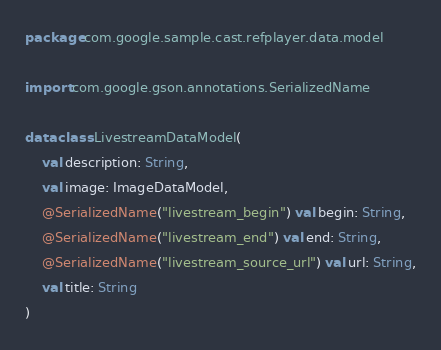Convert code to text. <code><loc_0><loc_0><loc_500><loc_500><_Kotlin_>package com.google.sample.cast.refplayer.data.model

import com.google.gson.annotations.SerializedName

data class LivestreamDataModel(
    val description: String,
    val image: ImageDataModel,
    @SerializedName("livestream_begin") val begin: String,
    @SerializedName("livestream_end") val end: String,
    @SerializedName("livestream_source_url") val url: String,
    val title: String
)
</code> 